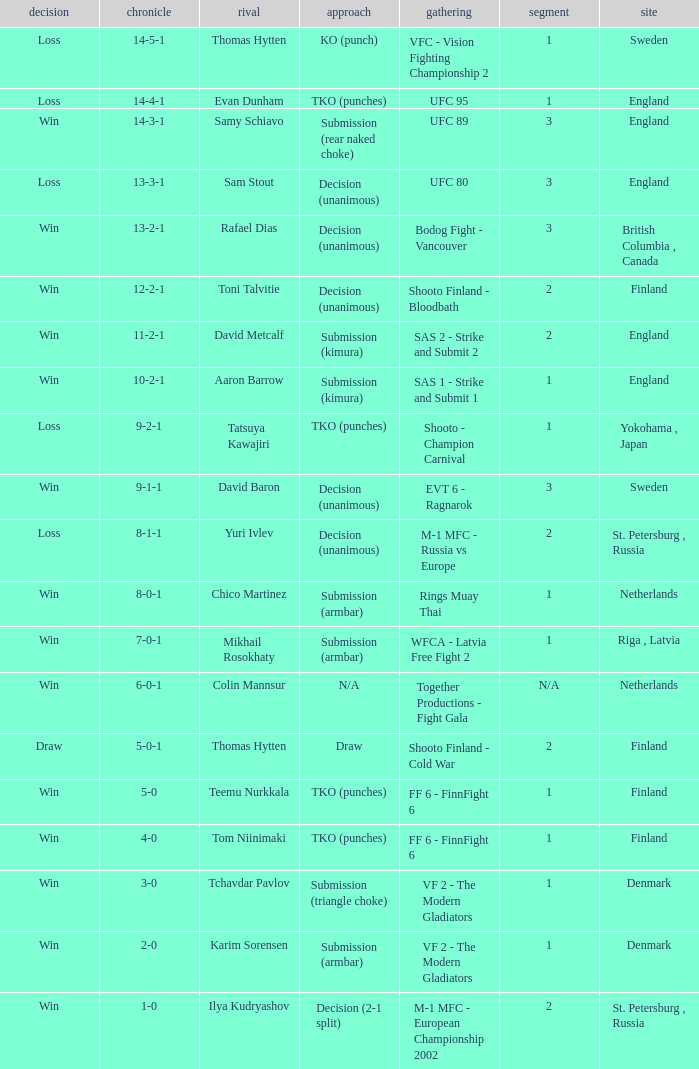Who was the opponent with a record of 14-4-1 and has a round of 1? Evan Dunham. 